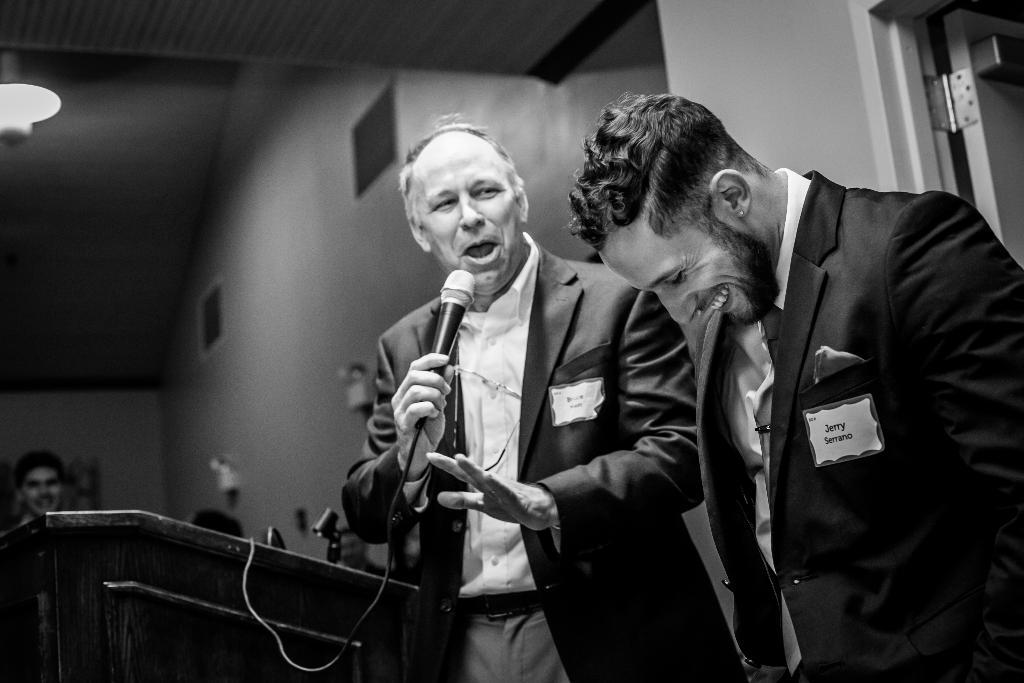How many people are in the image? There are two people in the image. What are the people doing in the image? The people are standing and smiling. What object is one person holding in the image? One person is holding a microphone. What is present in the image that might be used for speeches or presentations? There is a podium in the image. What can be seen in the background of the image? There is a light, a wall, and a few other persons in the background. What type of stem can be seen growing from the microphone in the image? There is no stem growing from the microphone in the image. How many forks are visible on the podium in the image? There are no forks present in the image. 